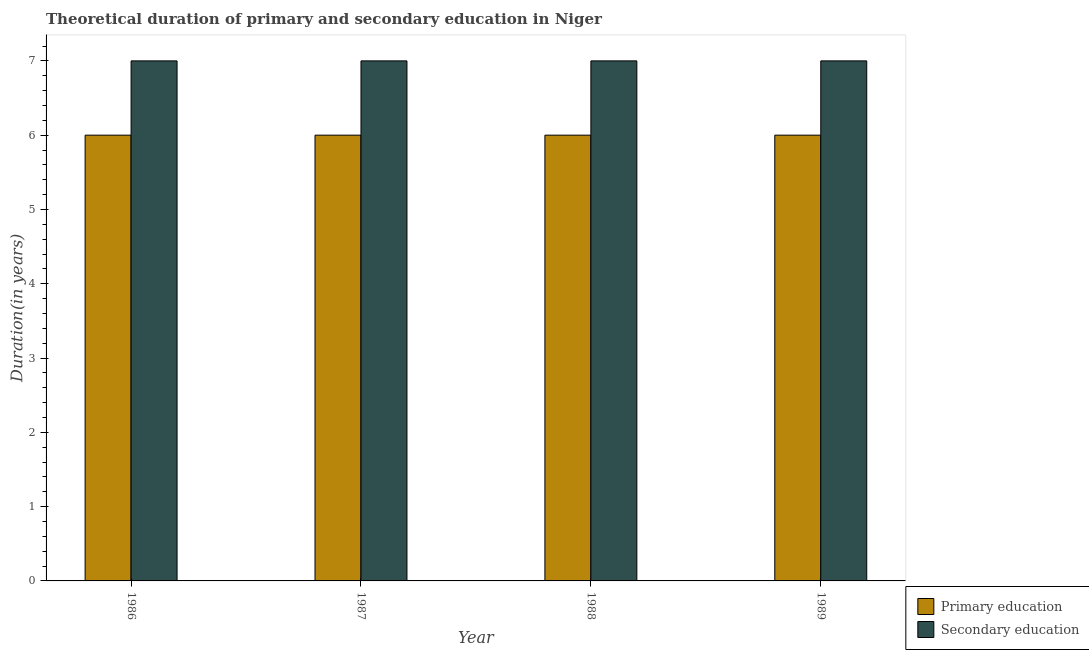How many different coloured bars are there?
Offer a very short reply. 2. Are the number of bars per tick equal to the number of legend labels?
Keep it short and to the point. Yes. Are the number of bars on each tick of the X-axis equal?
Keep it short and to the point. Yes. How many bars are there on the 4th tick from the left?
Your answer should be very brief. 2. In how many cases, is the number of bars for a given year not equal to the number of legend labels?
Ensure brevity in your answer.  0. What is the duration of secondary education in 1989?
Keep it short and to the point. 7. Across all years, what is the maximum duration of primary education?
Offer a terse response. 6. In which year was the duration of primary education maximum?
Offer a very short reply. 1986. What is the total duration of primary education in the graph?
Give a very brief answer. 24. What is the average duration of primary education per year?
Give a very brief answer. 6. In the year 1987, what is the difference between the duration of primary education and duration of secondary education?
Make the answer very short. 0. Is the difference between the duration of secondary education in 1986 and 1989 greater than the difference between the duration of primary education in 1986 and 1989?
Your answer should be compact. No. In how many years, is the duration of primary education greater than the average duration of primary education taken over all years?
Make the answer very short. 0. Is the sum of the duration of secondary education in 1986 and 1988 greater than the maximum duration of primary education across all years?
Ensure brevity in your answer.  Yes. What does the 2nd bar from the left in 1986 represents?
Your response must be concise. Secondary education. What does the 2nd bar from the right in 1987 represents?
Your answer should be compact. Primary education. What is the difference between two consecutive major ticks on the Y-axis?
Make the answer very short. 1. Are the values on the major ticks of Y-axis written in scientific E-notation?
Ensure brevity in your answer.  No. Does the graph contain grids?
Your answer should be very brief. No. Where does the legend appear in the graph?
Offer a terse response. Bottom right. How many legend labels are there?
Offer a very short reply. 2. How are the legend labels stacked?
Your answer should be compact. Vertical. What is the title of the graph?
Provide a short and direct response. Theoretical duration of primary and secondary education in Niger. What is the label or title of the Y-axis?
Your answer should be very brief. Duration(in years). What is the Duration(in years) of Primary education in 1986?
Give a very brief answer. 6. What is the Duration(in years) in Primary education in 1989?
Your answer should be compact. 6. What is the Duration(in years) of Secondary education in 1989?
Offer a very short reply. 7. Across all years, what is the maximum Duration(in years) of Secondary education?
Give a very brief answer. 7. Across all years, what is the minimum Duration(in years) of Primary education?
Your answer should be compact. 6. Across all years, what is the minimum Duration(in years) in Secondary education?
Keep it short and to the point. 7. What is the difference between the Duration(in years) of Secondary education in 1986 and that in 1987?
Offer a very short reply. 0. What is the difference between the Duration(in years) in Secondary education in 1986 and that in 1989?
Give a very brief answer. 0. What is the difference between the Duration(in years) of Primary education in 1987 and that in 1988?
Offer a very short reply. 0. What is the difference between the Duration(in years) of Secondary education in 1988 and that in 1989?
Offer a terse response. 0. What is the difference between the Duration(in years) in Primary education in 1986 and the Duration(in years) in Secondary education in 1989?
Your answer should be very brief. -1. What is the difference between the Duration(in years) of Primary education in 1987 and the Duration(in years) of Secondary education in 1988?
Give a very brief answer. -1. What is the average Duration(in years) in Primary education per year?
Offer a terse response. 6. In the year 1986, what is the difference between the Duration(in years) of Primary education and Duration(in years) of Secondary education?
Keep it short and to the point. -1. In the year 1987, what is the difference between the Duration(in years) of Primary education and Duration(in years) of Secondary education?
Give a very brief answer. -1. In the year 1989, what is the difference between the Duration(in years) in Primary education and Duration(in years) in Secondary education?
Offer a very short reply. -1. What is the ratio of the Duration(in years) in Primary education in 1986 to that in 1988?
Keep it short and to the point. 1. What is the ratio of the Duration(in years) in Secondary education in 1986 to that in 1988?
Your response must be concise. 1. What is the ratio of the Duration(in years) in Primary education in 1987 to that in 1988?
Offer a very short reply. 1. What is the ratio of the Duration(in years) in Secondary education in 1987 to that in 1988?
Your response must be concise. 1. What is the ratio of the Duration(in years) in Primary education in 1987 to that in 1989?
Your answer should be very brief. 1. What is the ratio of the Duration(in years) of Secondary education in 1988 to that in 1989?
Provide a succinct answer. 1. What is the difference between the highest and the second highest Duration(in years) in Secondary education?
Keep it short and to the point. 0. What is the difference between the highest and the lowest Duration(in years) of Primary education?
Give a very brief answer. 0. What is the difference between the highest and the lowest Duration(in years) in Secondary education?
Provide a succinct answer. 0. 